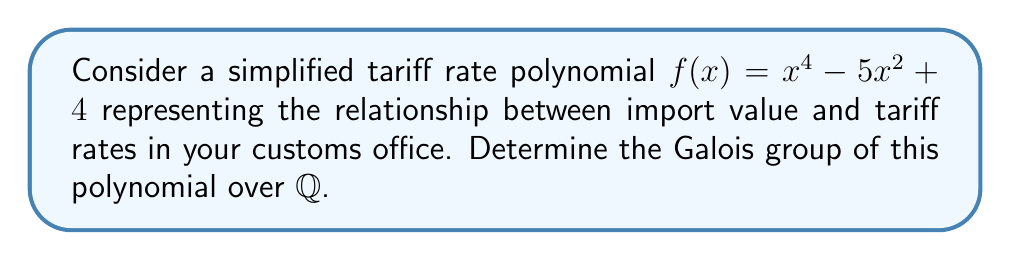Could you help me with this problem? To find the Galois group of $f(x) = x^4 - 5x^2 + 4$ over $\mathbb{Q}$, we'll follow these steps:

1) Factor the polynomial:
   $f(x) = x^4 - 5x^2 + 4 = (x^2 - 1)(x^2 - 4) = (x+1)(x-1)(x+2)(x-2)$

2) Identify the splitting field:
   The splitting field is $\mathbb{Q}(\alpha_1, \alpha_2, \alpha_3, \alpha_4)$ where $\alpha_1 = 1$, $\alpha_2 = -1$, $\alpha_3 = 2$, and $\alpha_4 = -2$.

3) Determine the degree of the splitting field extension:
   $[\mathbb{Q}(\alpha_1, \alpha_2, \alpha_3, \alpha_4) : \mathbb{Q}] = 1$ because all roots are rational.

4) Identify the possible group:
   Since the degree of the extension is 1, the Galois group must be trivial, i.e., it contains only the identity permutation.

5) Confirm the group structure:
   The Galois group $G = \{e\}$, where $e$ is the identity permutation.

Therefore, the Galois group of $f(x)$ over $\mathbb{Q}$ is the trivial group of order 1.
Answer: The trivial group $\{e\}$ 